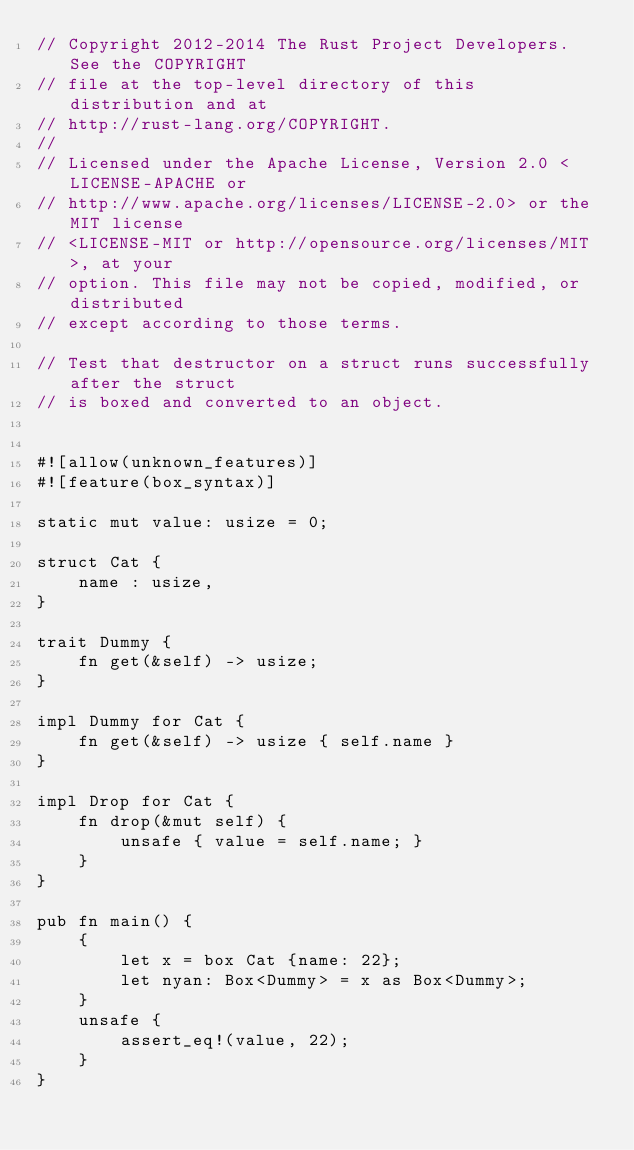Convert code to text. <code><loc_0><loc_0><loc_500><loc_500><_Rust_>// Copyright 2012-2014 The Rust Project Developers. See the COPYRIGHT
// file at the top-level directory of this distribution and at
// http://rust-lang.org/COPYRIGHT.
//
// Licensed under the Apache License, Version 2.0 <LICENSE-APACHE or
// http://www.apache.org/licenses/LICENSE-2.0> or the MIT license
// <LICENSE-MIT or http://opensource.org/licenses/MIT>, at your
// option. This file may not be copied, modified, or distributed
// except according to those terms.

// Test that destructor on a struct runs successfully after the struct
// is boxed and converted to an object.


#![allow(unknown_features)]
#![feature(box_syntax)]

static mut value: usize = 0;

struct Cat {
    name : usize,
}

trait Dummy {
    fn get(&self) -> usize;
}

impl Dummy for Cat {
    fn get(&self) -> usize { self.name }
}

impl Drop for Cat {
    fn drop(&mut self) {
        unsafe { value = self.name; }
    }
}

pub fn main() {
    {
        let x = box Cat {name: 22};
        let nyan: Box<Dummy> = x as Box<Dummy>;
    }
    unsafe {
        assert_eq!(value, 22);
    }
}
</code> 